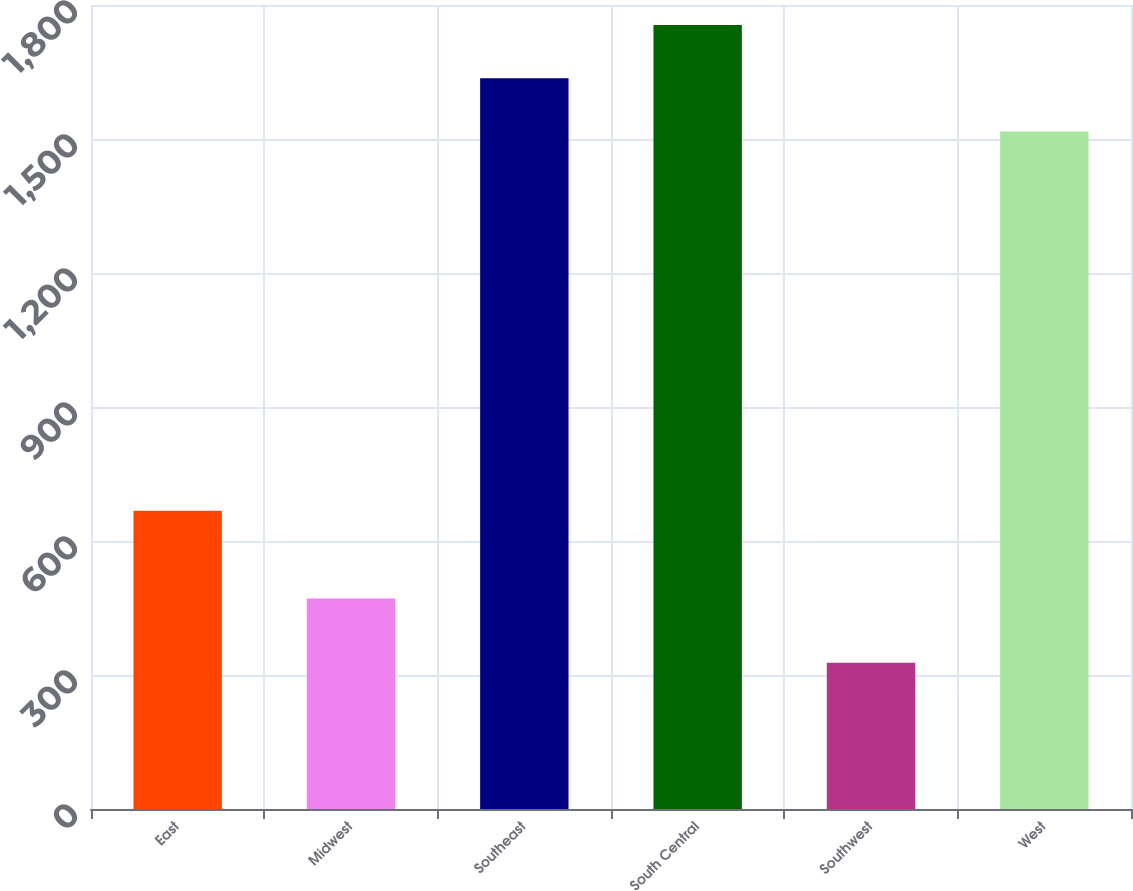Convert chart to OTSL. <chart><loc_0><loc_0><loc_500><loc_500><bar_chart><fcel>East<fcel>Midwest<fcel>Southeast<fcel>South Central<fcel>Southwest<fcel>West<nl><fcel>667.8<fcel>471.3<fcel>1636.11<fcel>1755.42<fcel>327.7<fcel>1516.8<nl></chart> 